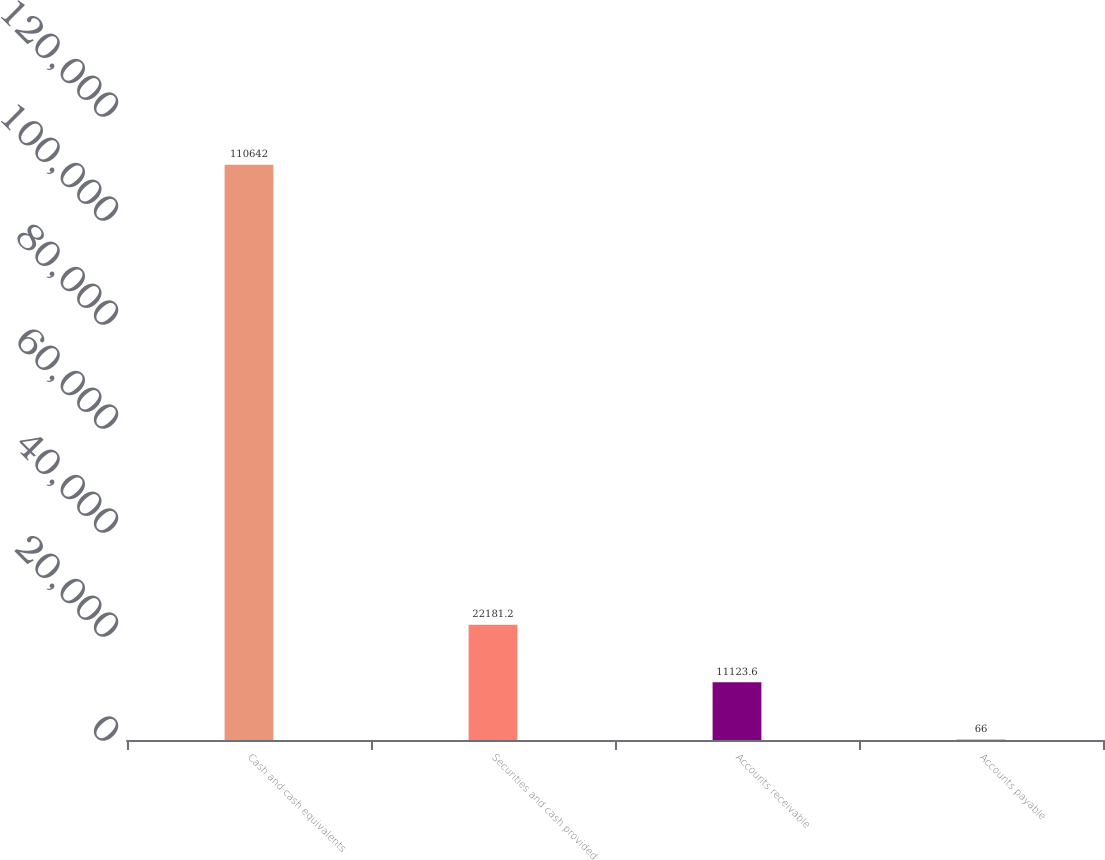Convert chart. <chart><loc_0><loc_0><loc_500><loc_500><bar_chart><fcel>Cash and cash equivalents<fcel>Securities and cash provided<fcel>Accounts receivable<fcel>Accounts payable<nl><fcel>110642<fcel>22181.2<fcel>11123.6<fcel>66<nl></chart> 